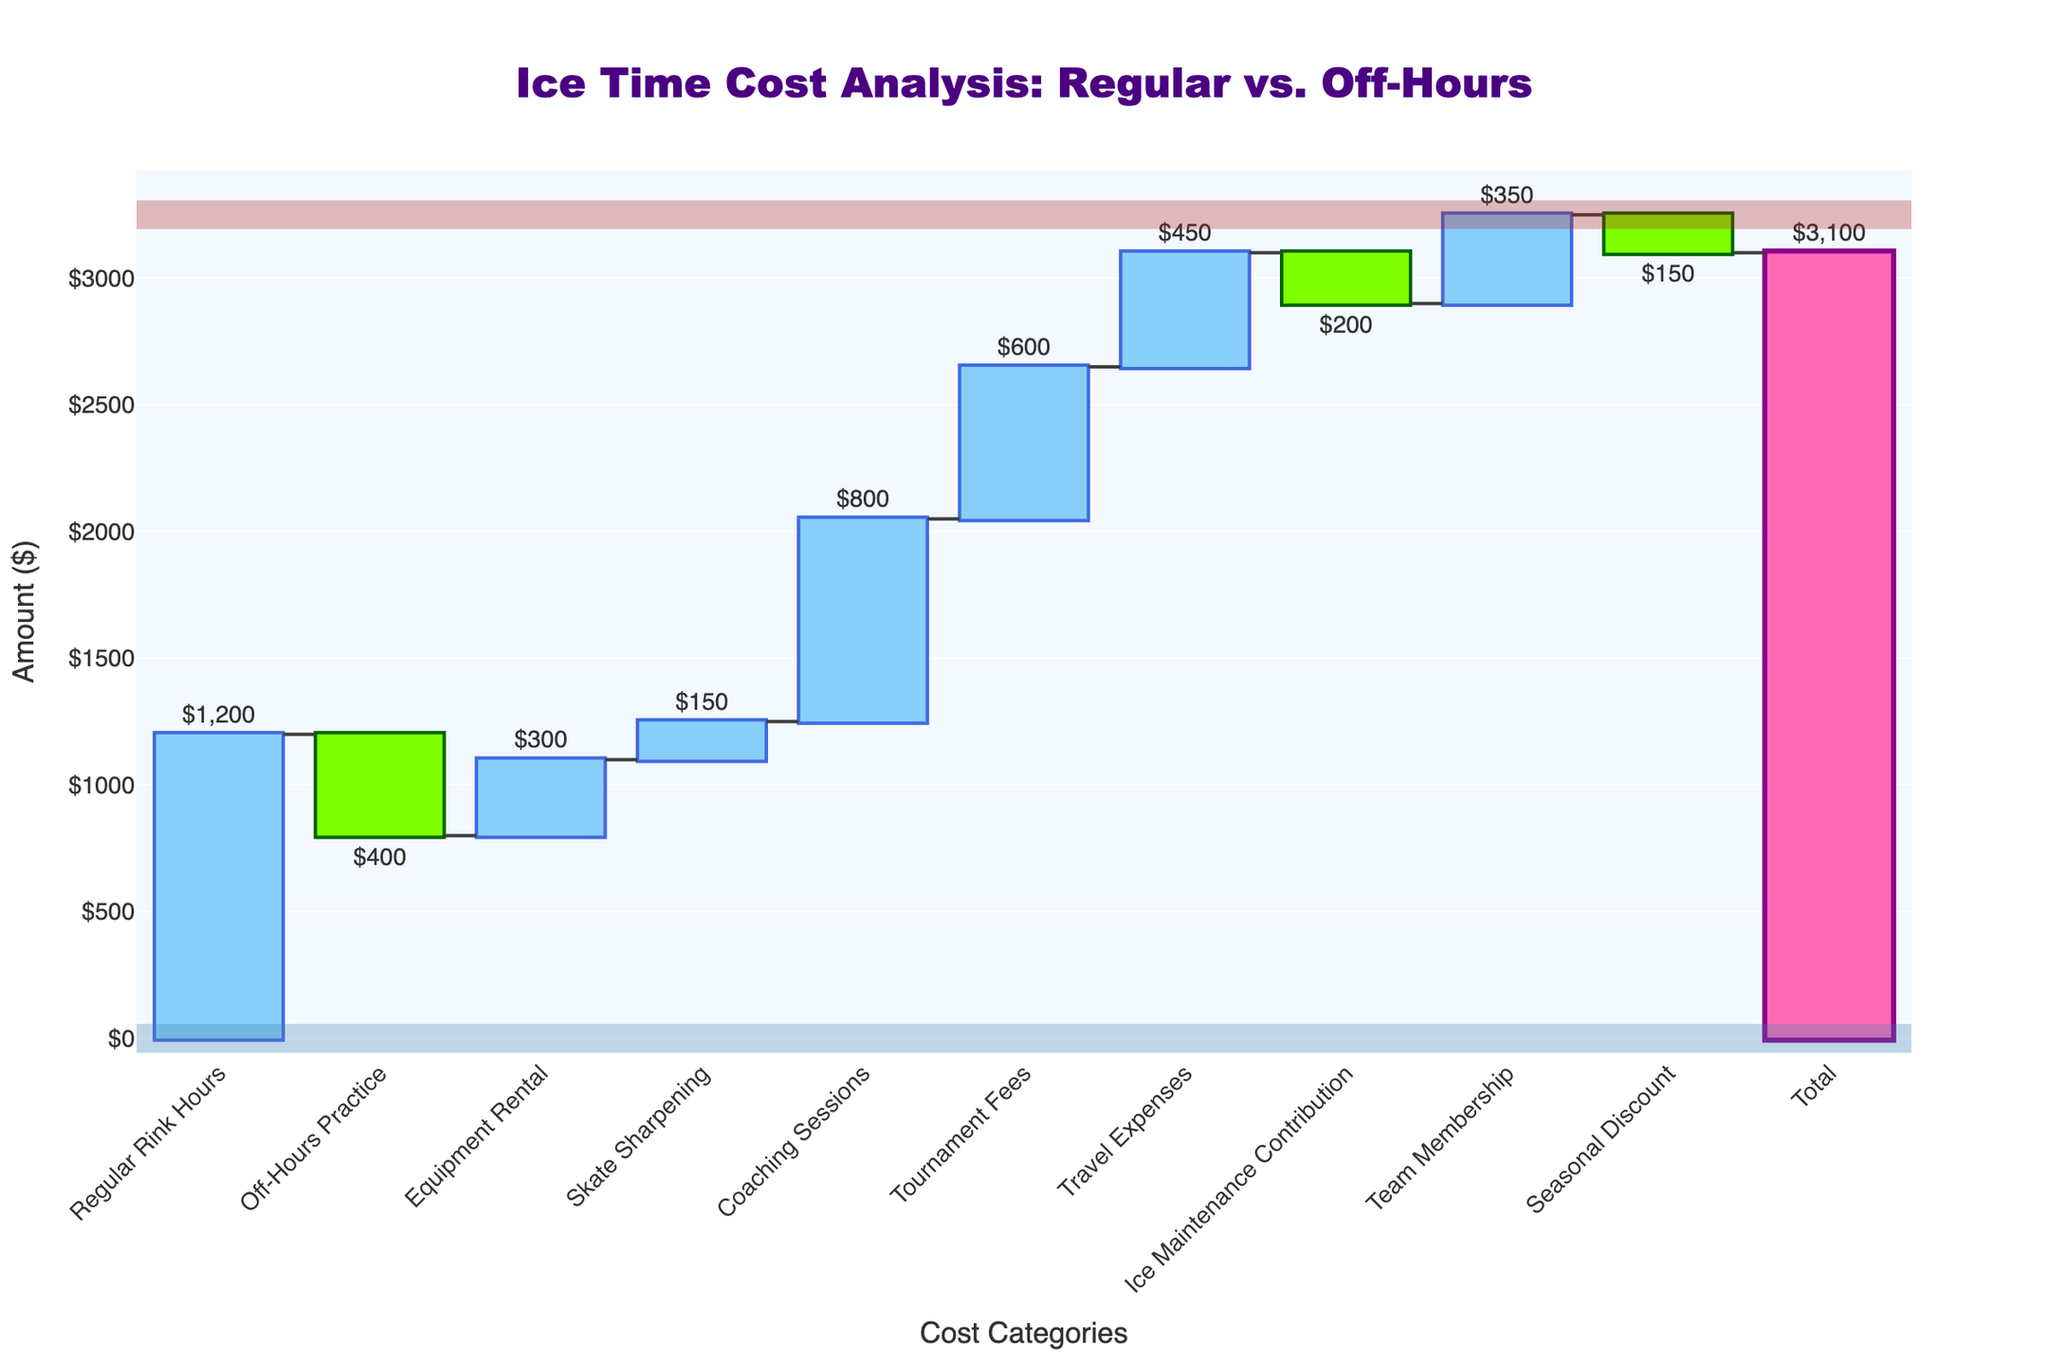what is the total amount for Ice Time Cost Analysis? The final bar at the end of the Waterfall Chart is labeled "Total" and shows the combined amount of all positive and negative contributions.
Answer: $3,100 How much did the off-hours practice sessions reduce the cost by? The figure shows a downward bar labeled "Off-Hours Practice" with an amount of -$400 indicated next to it. This is the amount by which the off-hours practice sessions reduced the total cost.
Answer: $400 Which cost category has the highest positive contribution? The highest upward bar in the Waterfall Chart belongs to "Coaching Sessions" with an amount of $800 indicated next to it.
Answer: Coaching Sessions What is the combined contribution of Equipment Rental and Skate Sharpening? You need to sum the values of the "Equipment Rental" and "Skate Sharpening" bars. Equipment Rental contributes $300 and Skate Sharpening contributes $150. Therefore, $300 + $150 = $450.
Answer: $450 Are regular rink hours more costly than off-hours practice sessions? The Waterfall Chart shows "Regular Rink Hours" as $1,200 and "Off-Hours Practice" as -$400. Since $1,200 is greater than -$400, regular rink hours are indeed more costly.
Answer: Yes What is the difference in expense between tournaments fees and travel expenses? The figure shows "Tournament Fees" with a value of $600 and "Travel Expenses" with a value of $450. The difference is calculated by subtracting $450 from $600. Thus, the difference is $600 - $450 = $150.
Answer: $150 What is the result after applying the seasonal discount? The seasonal discount is represented by a downward bar labeled "Seasonal Discount" with an amount of -$150. To find the result after applying this discount, you would subtract $150 from previous cumulative amounts shown in the chart. However, since it is a specific step in the chart, it is easiest to note the $150 deduction visually.
Answer: -$150 